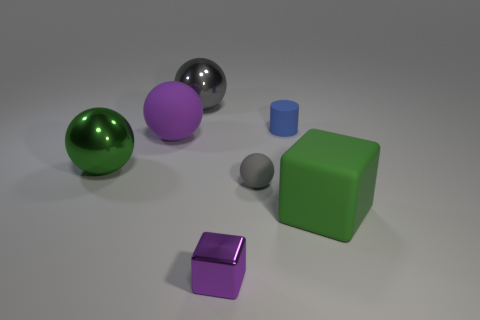Subtract all tiny rubber spheres. How many spheres are left? 3 Subtract all purple cubes. How many cubes are left? 1 Add 1 big blue spheres. How many objects exist? 8 Subtract all blocks. How many objects are left? 5 Subtract all yellow cylinders. How many purple spheres are left? 1 Add 7 tiny gray rubber spheres. How many tiny gray rubber spheres exist? 8 Subtract 0 cyan cubes. How many objects are left? 7 Subtract 1 cylinders. How many cylinders are left? 0 Subtract all green cylinders. Subtract all gray balls. How many cylinders are left? 1 Subtract all tiny gray matte cubes. Subtract all big green rubber things. How many objects are left? 6 